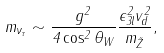Convert formula to latex. <formula><loc_0><loc_0><loc_500><loc_500>m _ { \nu _ { \tau } } \sim \frac { g ^ { 2 } } { 4 \cos ^ { 2 } \theta _ { W } } \frac { \epsilon _ { 3 l } ^ { 2 } v _ { d } ^ { 2 } } { m _ { \tilde { Z } } } ,</formula> 